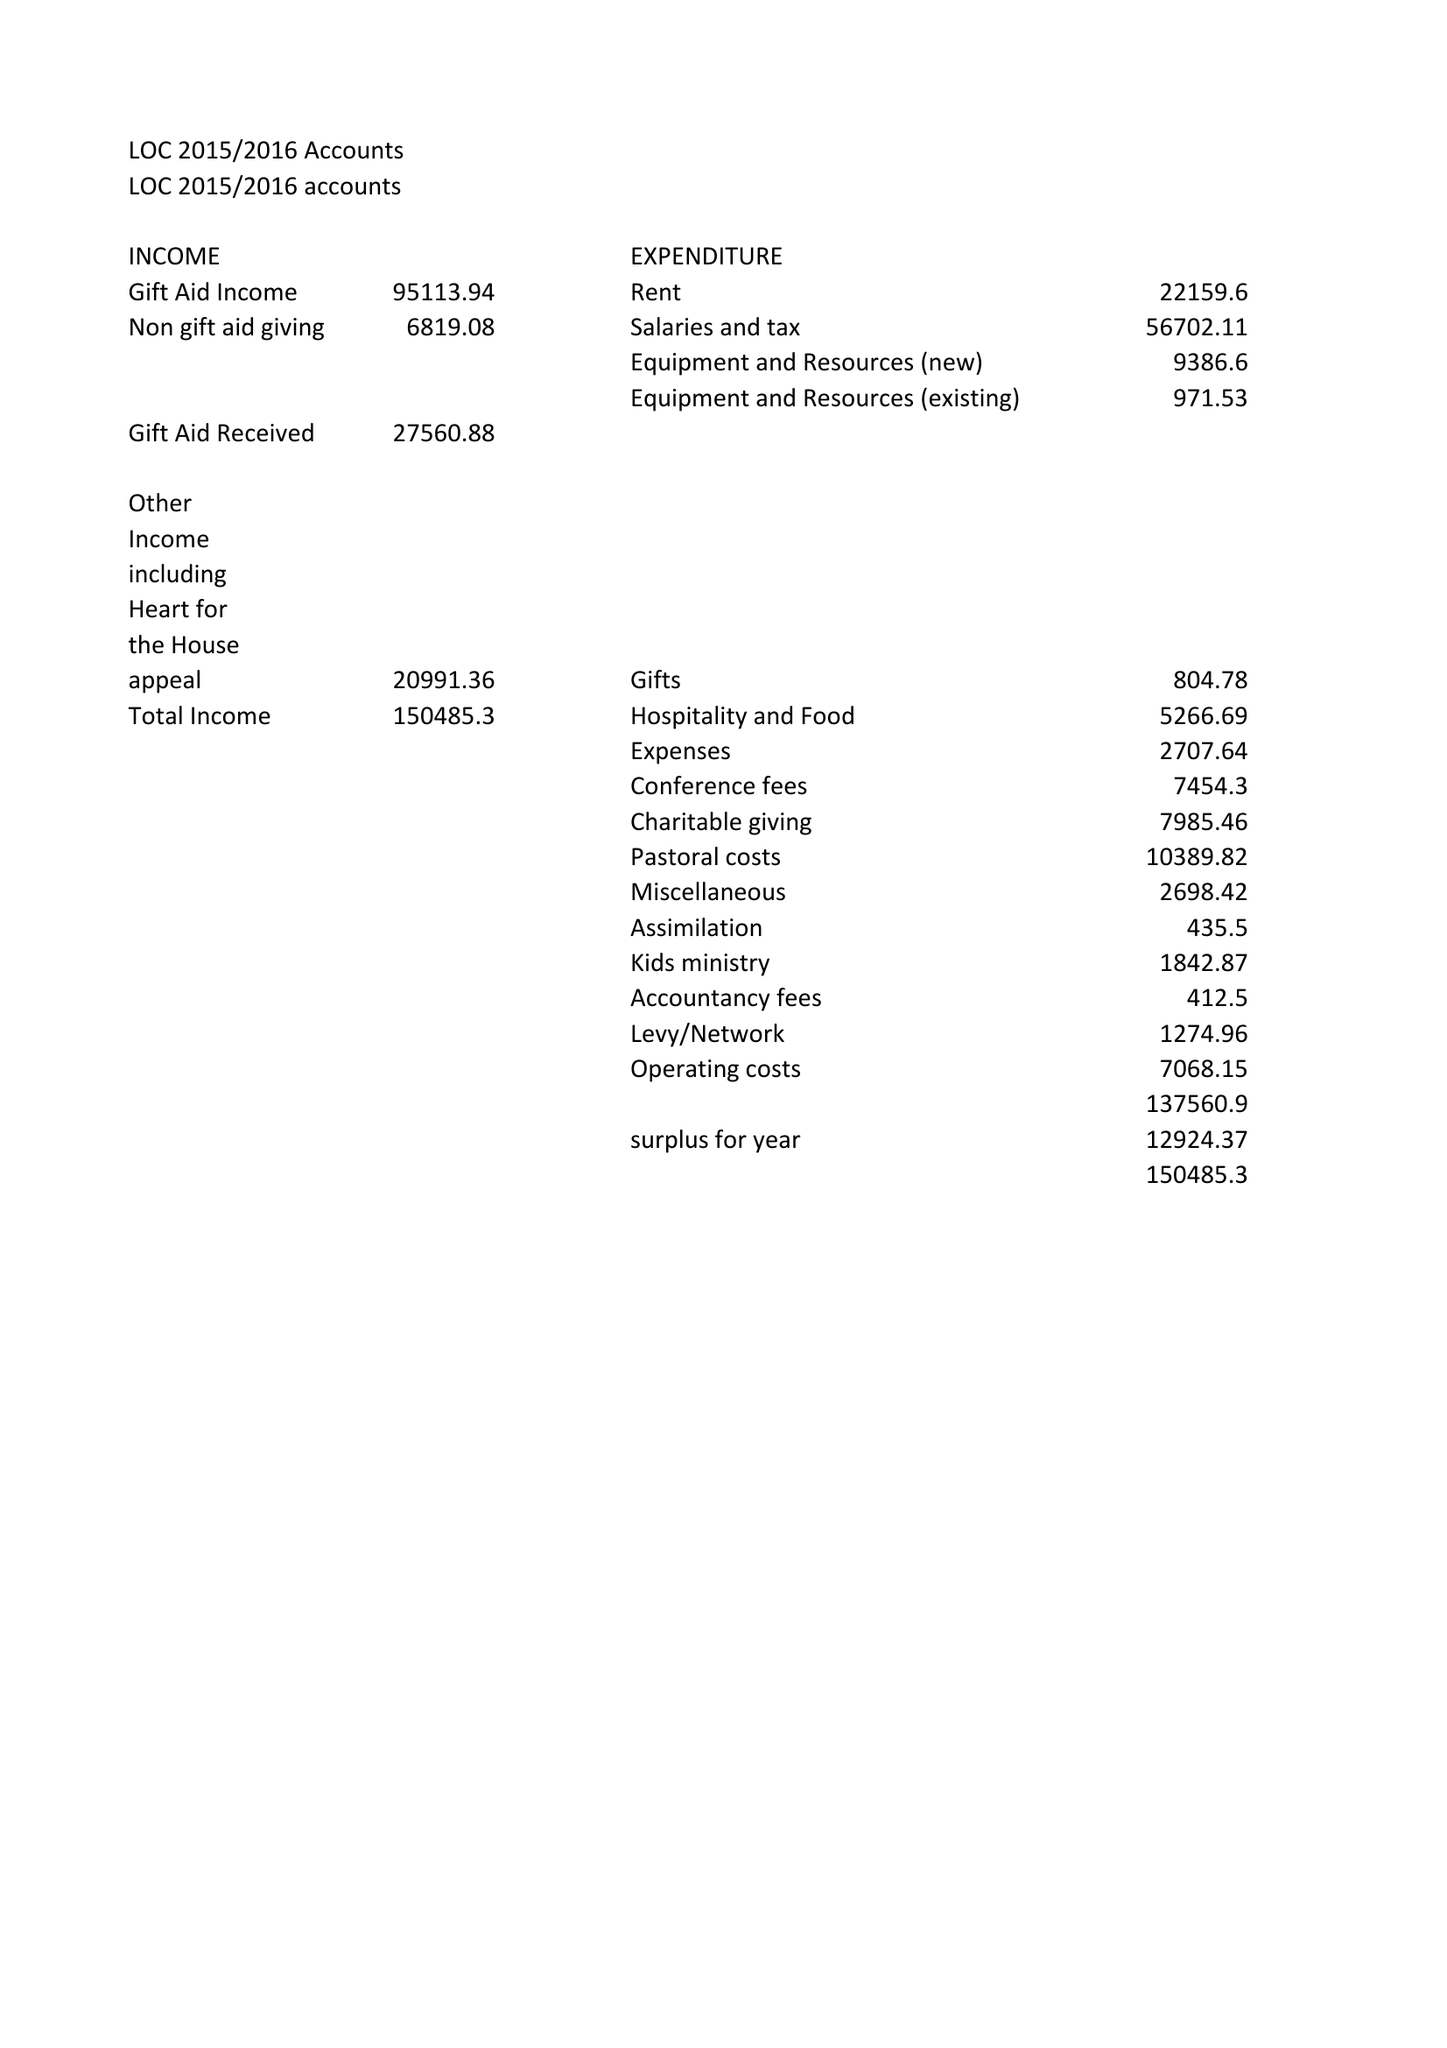What is the value for the charity_name?
Answer the question using a single word or phrase. Liverpool One Church 